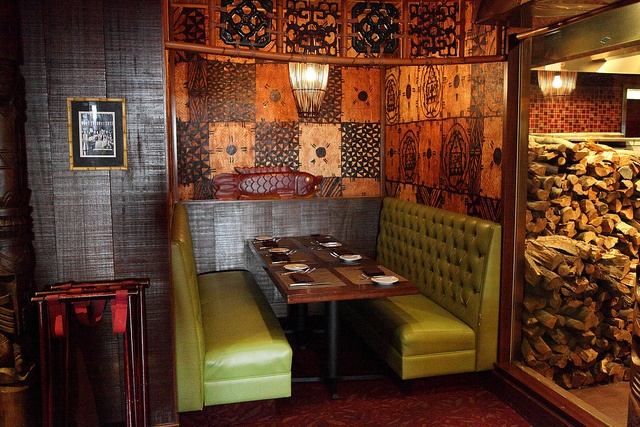Describe the objects in this image and their specific colors. I can see couch in black, olive, and maroon tones, couch in black, olive, and maroon tones, chair in black, olive, and maroon tones, dining table in black, maroon, and gray tones, and knife in black, gray, and white tones in this image. 